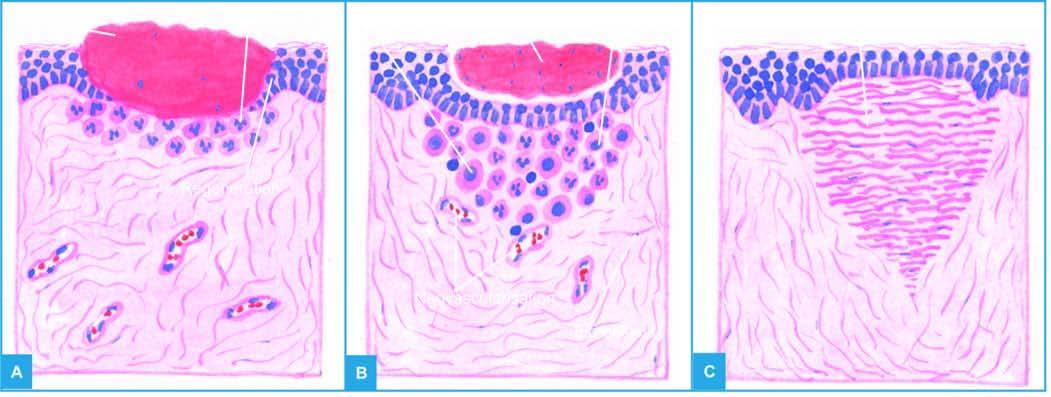does epithelial spur from the margins of wound?
Answer the question using a single word or phrase. Yes 